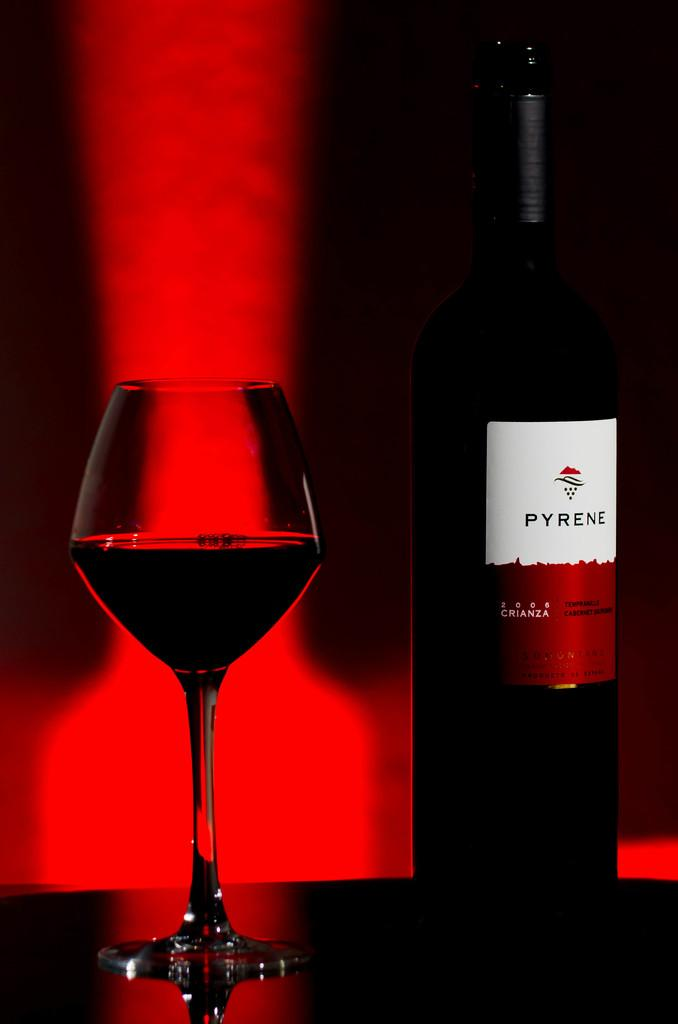What is one of the objects visible in the image? There is a glass in the image. What is another object visible in the image? There is a bottle in the image. Can you describe the bottle in the image? The bottle has text written on it. How many grapes are in the glass in the image? There are no grapes visible in the image; only a glass and a bottle are present. Is there a baby in the image? There is no baby present in the image. 